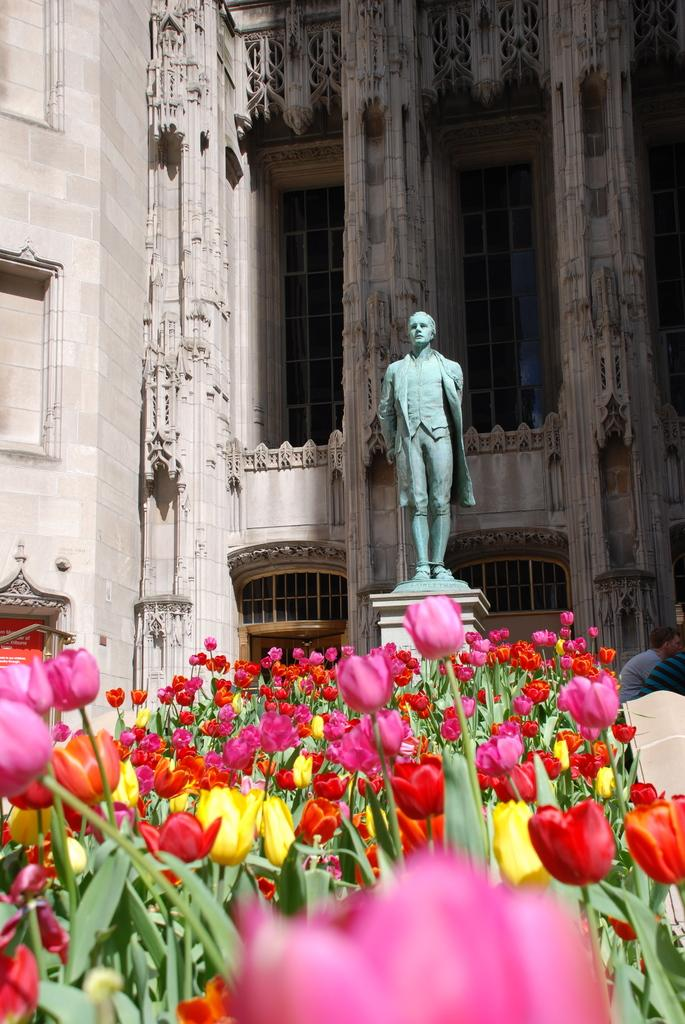What is the main subject of the picture? The main subject of the picture is a statue of a man. What type of plants can be seen in the picture? There are flower plants in the picture. What type of structure is visible in the picture? There is a building in the picture. What other objects can be seen in the picture besides the statue, plants, and building? There are other objects in the picture. What type of scent can be detected from the earth in the image? There is no mention of earth or any scent in the image, so it is not possible to answer that question. 